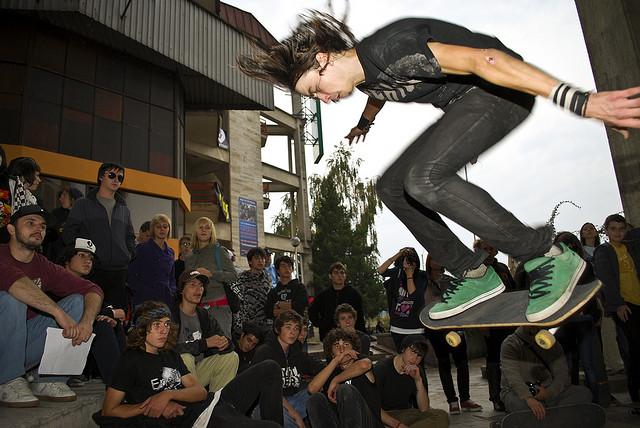What color are his shoes?
Concise answer only. Green. What shoe company is the sponsor of this skateboarding event?
Answer briefly. Vans. What color are the boy's socks?
Keep it brief. White. What is he doing?
Keep it brief. Skateboarding. Is he too close to the crowd?
Keep it brief. Yes. What color are the boy's shoes?
Concise answer only. Green. Is the man holding the board?
Quick response, please. No. What color shirt is the girl wearing?
Short answer required. Black. Is this a competition?
Answer briefly. Yes. 